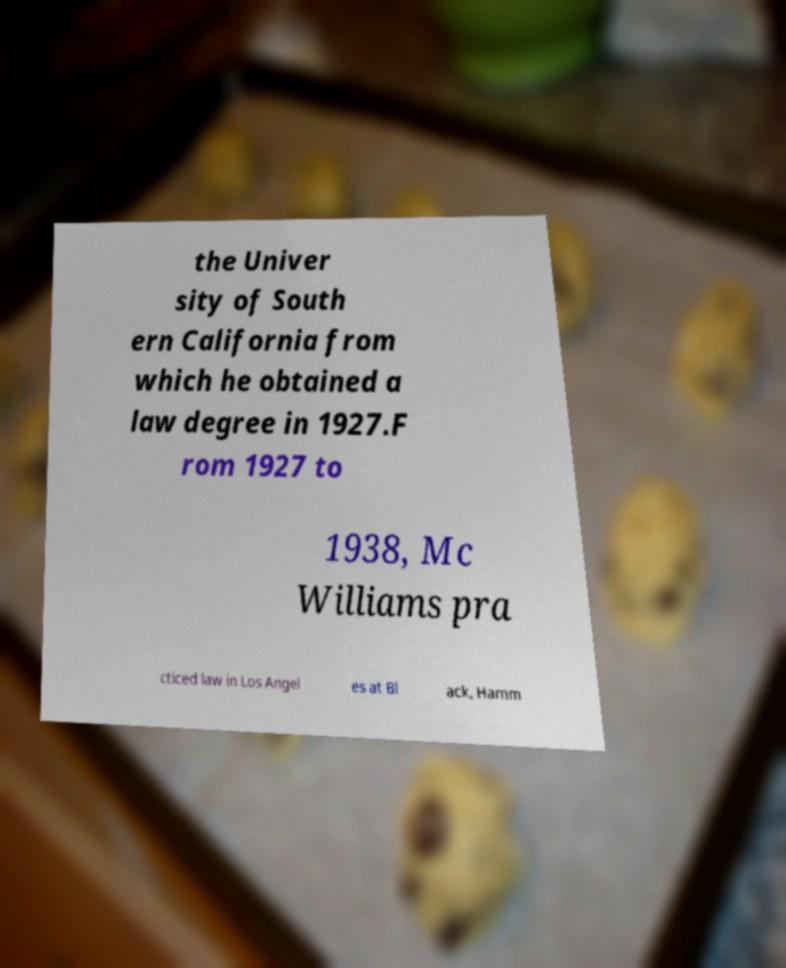Can you read and provide the text displayed in the image?This photo seems to have some interesting text. Can you extract and type it out for me? the Univer sity of South ern California from which he obtained a law degree in 1927.F rom 1927 to 1938, Mc Williams pra cticed law in Los Angel es at Bl ack, Hamm 